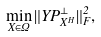Convert formula to latex. <formula><loc_0><loc_0><loc_500><loc_500>\min _ { X \in \Omega } \| Y P _ { X ^ { H } } ^ { \bot } \| _ { F } ^ { 2 } ,</formula> 